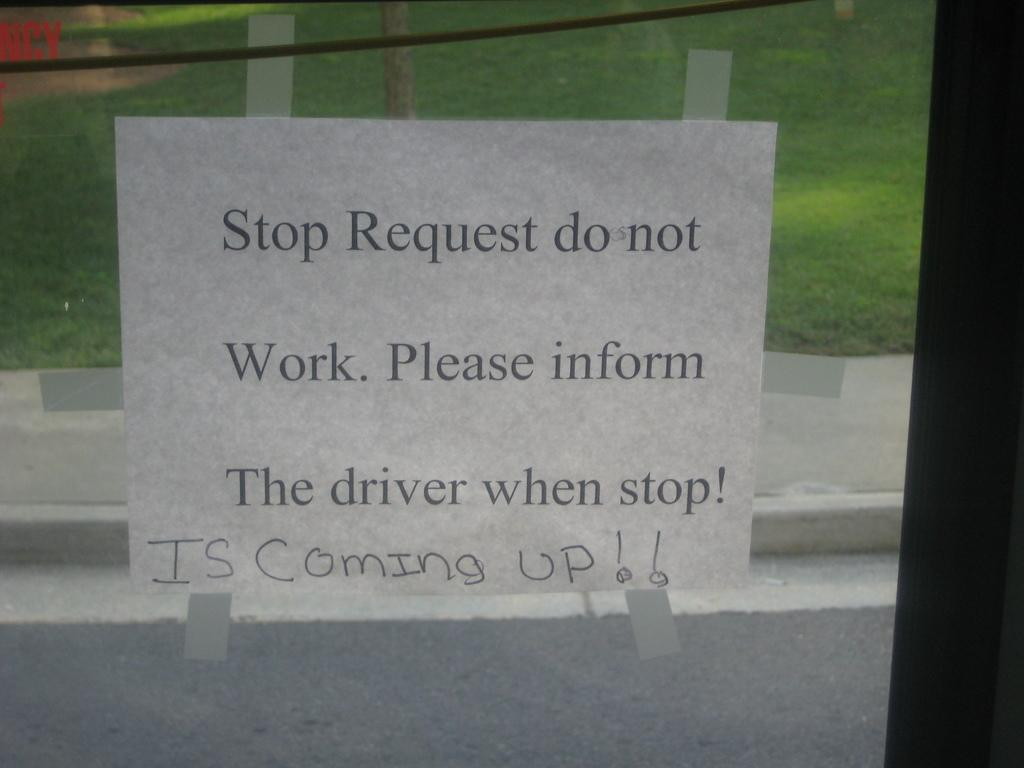What is present on the glass surface in the image? There is a poster on the glass surface in the image. How is the poster attached to the glass surface? The poster is stuck on the glass surface. What can be seen through the glass in the image? Grass and a tree are visible through the glass in the image. Can you tell me how many parents are running in the springtime scene depicted on the poster? There is no springtime scene or parents running on the poster; it is a poster with a different subject. 